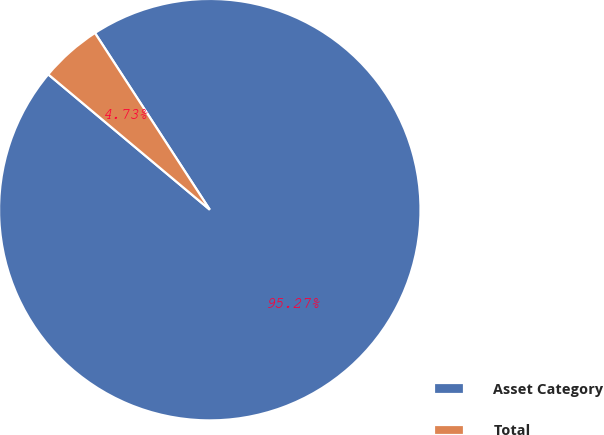Convert chart to OTSL. <chart><loc_0><loc_0><loc_500><loc_500><pie_chart><fcel>Asset Category<fcel>Total<nl><fcel>95.27%<fcel>4.73%<nl></chart> 